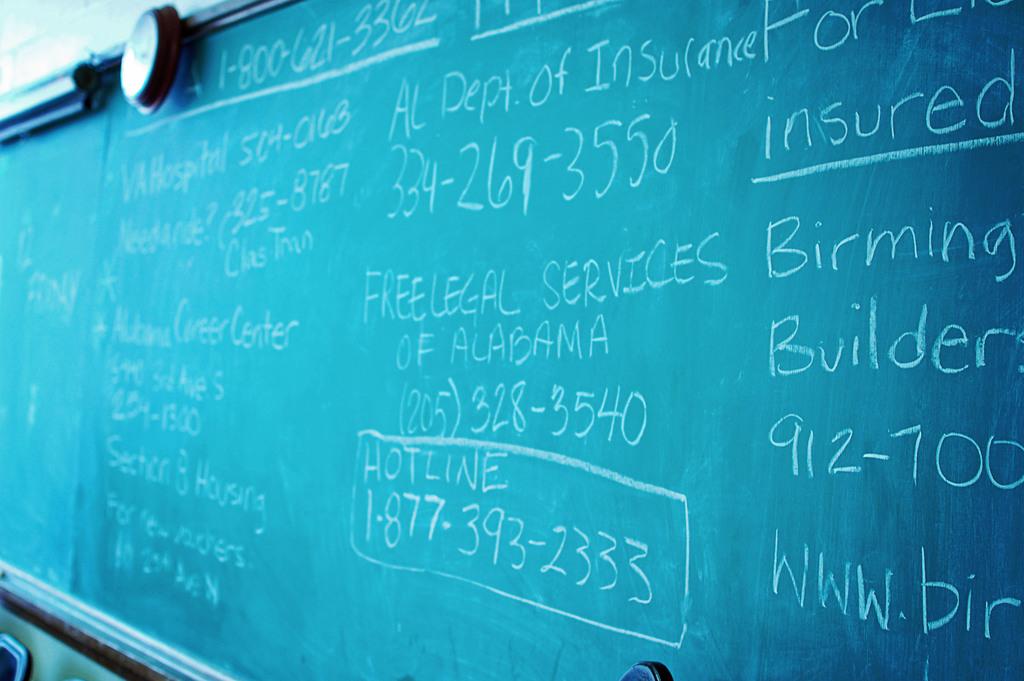What is the area code for al dept if insurance?
Give a very brief answer. 334. 